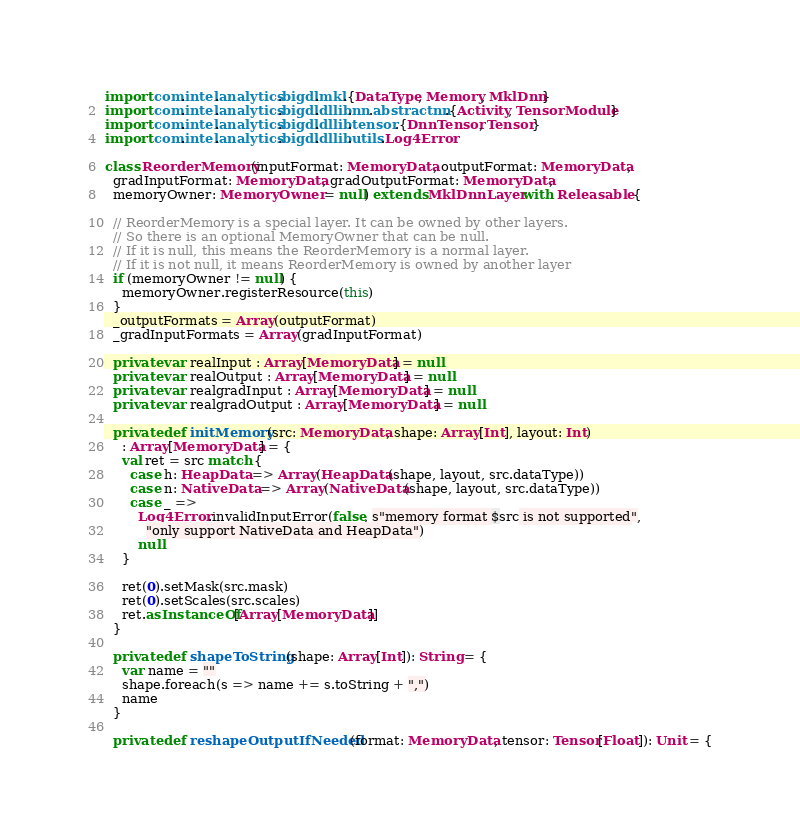<code> <loc_0><loc_0><loc_500><loc_500><_Scala_>import com.intel.analytics.bigdl.mkl.{DataType, Memory, MklDnn}
import com.intel.analytics.bigdl.dllib.nn.abstractnn.{Activity, TensorModule}
import com.intel.analytics.bigdl.dllib.tensor.{DnnTensor, Tensor}
import com.intel.analytics.bigdl.dllib.utils.Log4Error

class ReorderMemory(inputFormat: MemoryData, outputFormat: MemoryData,
  gradInputFormat: MemoryData, gradOutputFormat: MemoryData,
  memoryOwner: MemoryOwner = null) extends MklDnnLayer with Releasable {

  // ReorderMemory is a special layer. It can be owned by other layers.
  // So there is an optional MemoryOwner that can be null.
  // If it is null, this means the ReorderMemory is a normal layer.
  // If it is not null, it means ReorderMemory is owned by another layer
  if (memoryOwner != null) {
    memoryOwner.registerResource(this)
  }
  _outputFormats = Array(outputFormat)
  _gradInputFormats = Array(gradInputFormat)

  private var realInput : Array[MemoryData] = null
  private var realOutput : Array[MemoryData] = null
  private var realgradInput : Array[MemoryData] = null
  private var realgradOutput : Array[MemoryData] = null

  private def initMemory(src: MemoryData, shape: Array[Int], layout: Int)
    : Array[MemoryData] = {
    val ret = src match {
      case h: HeapData => Array(HeapData(shape, layout, src.dataType))
      case n: NativeData => Array(NativeData(shape, layout, src.dataType))
      case _ =>
        Log4Error.invalidInputError(false, s"memory format $src is not supported",
          "only support NativeData and HeapData")
        null
    }

    ret(0).setMask(src.mask)
    ret(0).setScales(src.scales)
    ret.asInstanceOf[Array[MemoryData]]
  }

  private def shapeToString(shape: Array[Int]): String = {
    var name = ""
    shape.foreach(s => name += s.toString + ",")
    name
  }

  private def reshapeOutputIfNeeded(format: MemoryData, tensor: Tensor[Float]): Unit = {</code> 